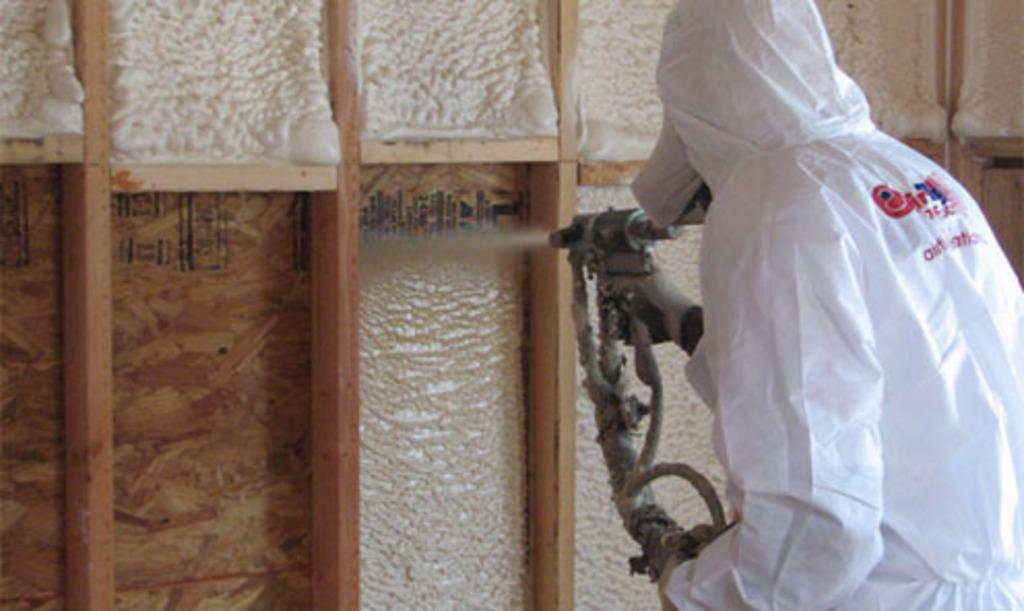What can be seen in the image? There is a person in the image. What is the person holding? The person is holding something. Can you describe the person's clothing? The person is wearing a white dress. What other objects are visible in the image? There are wooden sticks in the image. What colors can be seen in the background of the image? The background of the image is in white and brown colors. What type of gold plate is being used by the person in the image? There is no gold plate present in the image. 